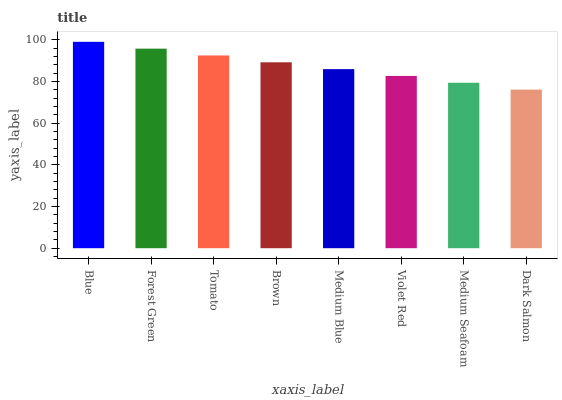Is Dark Salmon the minimum?
Answer yes or no. Yes. Is Blue the maximum?
Answer yes or no. Yes. Is Forest Green the minimum?
Answer yes or no. No. Is Forest Green the maximum?
Answer yes or no. No. Is Blue greater than Forest Green?
Answer yes or no. Yes. Is Forest Green less than Blue?
Answer yes or no. Yes. Is Forest Green greater than Blue?
Answer yes or no. No. Is Blue less than Forest Green?
Answer yes or no. No. Is Brown the high median?
Answer yes or no. Yes. Is Medium Blue the low median?
Answer yes or no. Yes. Is Blue the high median?
Answer yes or no. No. Is Brown the low median?
Answer yes or no. No. 